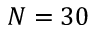<formula> <loc_0><loc_0><loc_500><loc_500>N = 3 0</formula> 